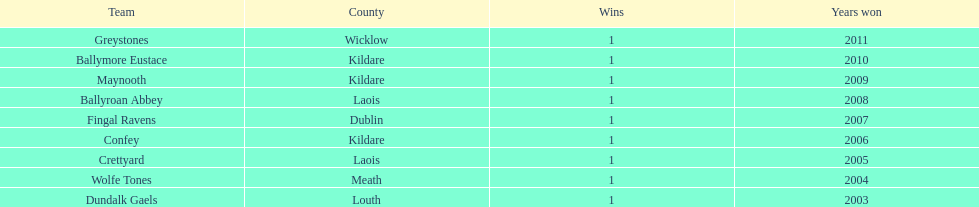What team comes before confey Fingal Ravens. 